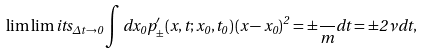<formula> <loc_0><loc_0><loc_500><loc_500>\lim \lim i t s _ { \Delta t \rightarrow 0 } \int d x _ { 0 } p _ { \pm } ^ { \prime } ( x , t ; x _ { 0 } , t _ { 0 } ) \left ( x - x _ { 0 } \right ) ^ { 2 } = \pm \frac { } { m } d t = \pm 2 \nu d t ,</formula> 